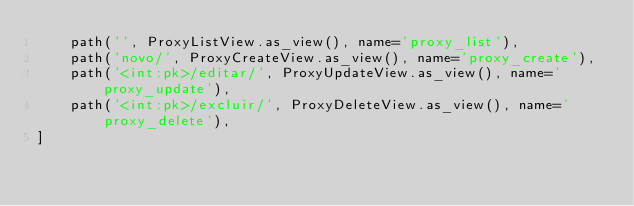Convert code to text. <code><loc_0><loc_0><loc_500><loc_500><_Python_>    path('', ProxyListView.as_view(), name='proxy_list'),
    path('novo/', ProxyCreateView.as_view(), name='proxy_create'),
    path('<int:pk>/editar/', ProxyUpdateView.as_view(), name='proxy_update'),
    path('<int:pk>/excluir/', ProxyDeleteView.as_view(), name='proxy_delete'),
]
</code> 